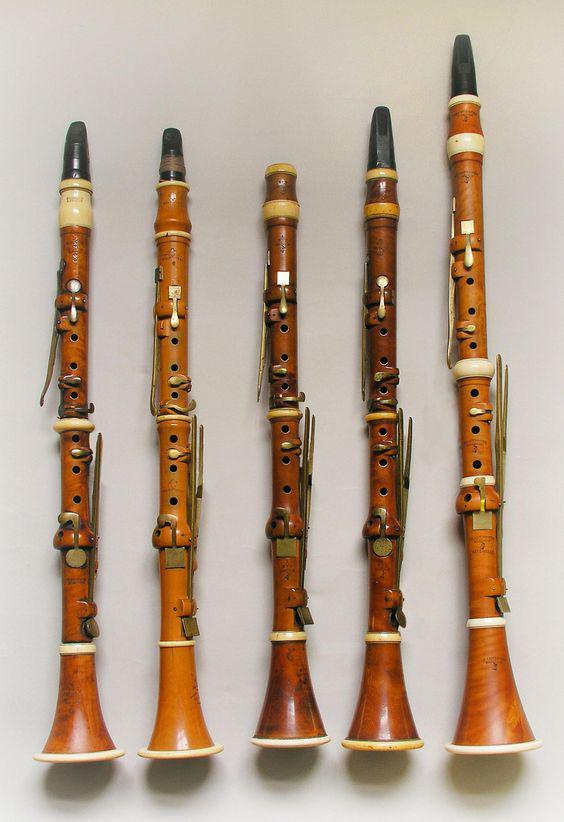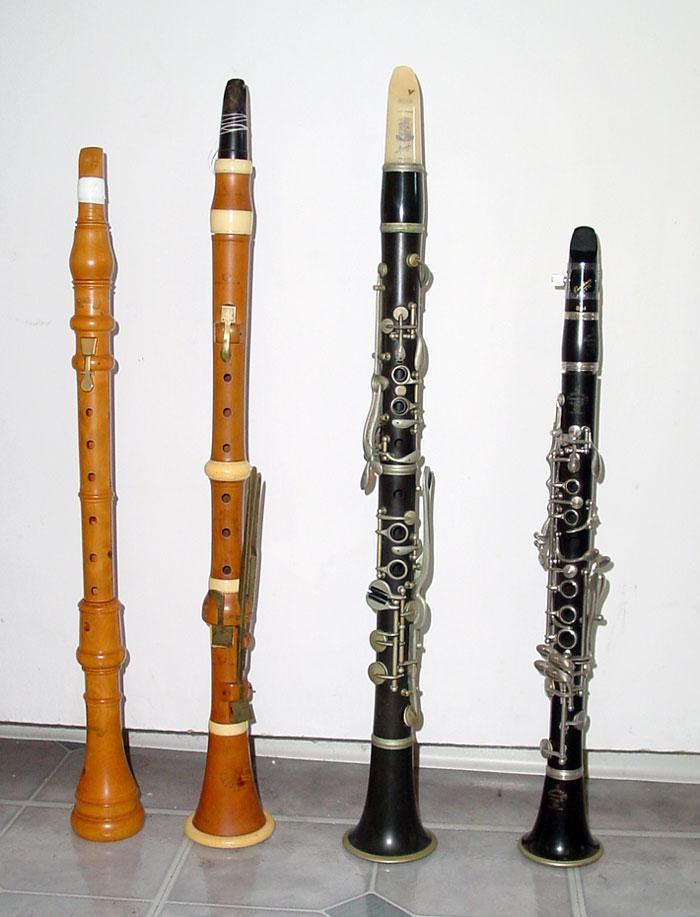The first image is the image on the left, the second image is the image on the right. For the images shown, is this caption "There are three clarinets in the right image." true? Answer yes or no. No. The first image is the image on the left, the second image is the image on the right. Analyze the images presented: Is the assertion "One image contains exactly three wind instruments and the other contains exactly five." valid? Answer yes or no. No. 